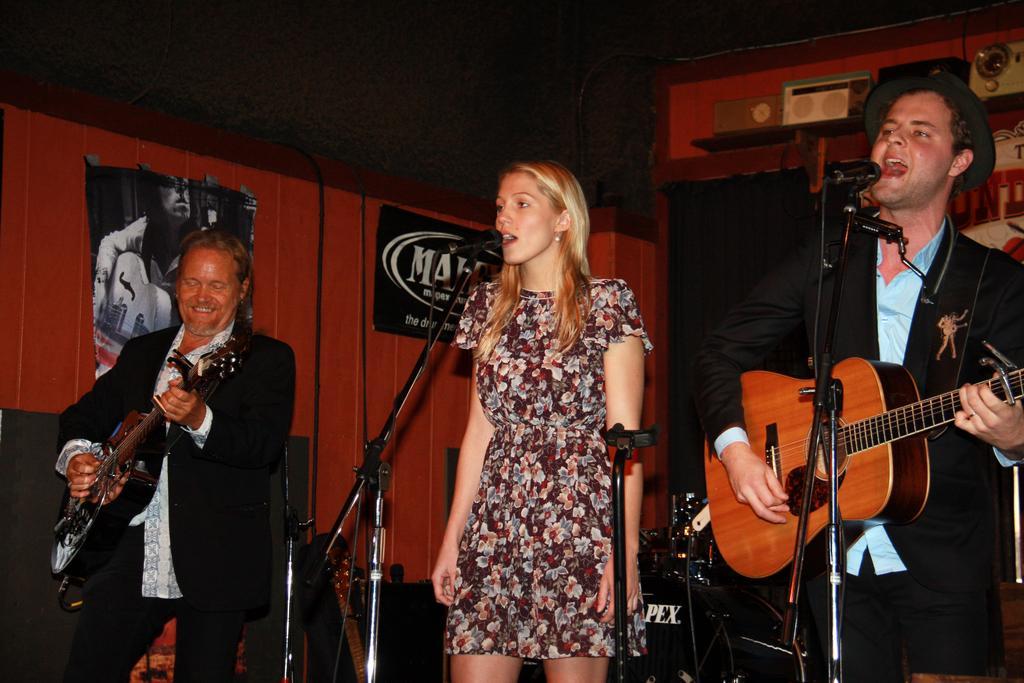Could you give a brief overview of what you see in this image? There is a woman who is standing at the center and she is singing. There is a man who is holding guitar in his hands and he is singing and he is right to a woman. There is a man who is left to woman he also holding guitar in his hands and he is smiling. 